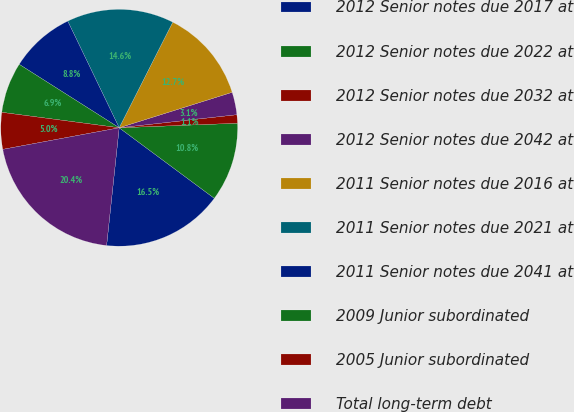<chart> <loc_0><loc_0><loc_500><loc_500><pie_chart><fcel>2012 Senior notes due 2017 at<fcel>2012 Senior notes due 2022 at<fcel>2012 Senior notes due 2032 at<fcel>2012 Senior notes due 2042 at<fcel>2011 Senior notes due 2016 at<fcel>2011 Senior notes due 2021 at<fcel>2011 Senior notes due 2041 at<fcel>2009 Junior subordinated<fcel>2005 Junior subordinated<fcel>Total long-term debt<nl><fcel>16.54%<fcel>10.77%<fcel>1.15%<fcel>3.08%<fcel>12.69%<fcel>14.62%<fcel>8.85%<fcel>6.92%<fcel>5.0%<fcel>20.39%<nl></chart> 